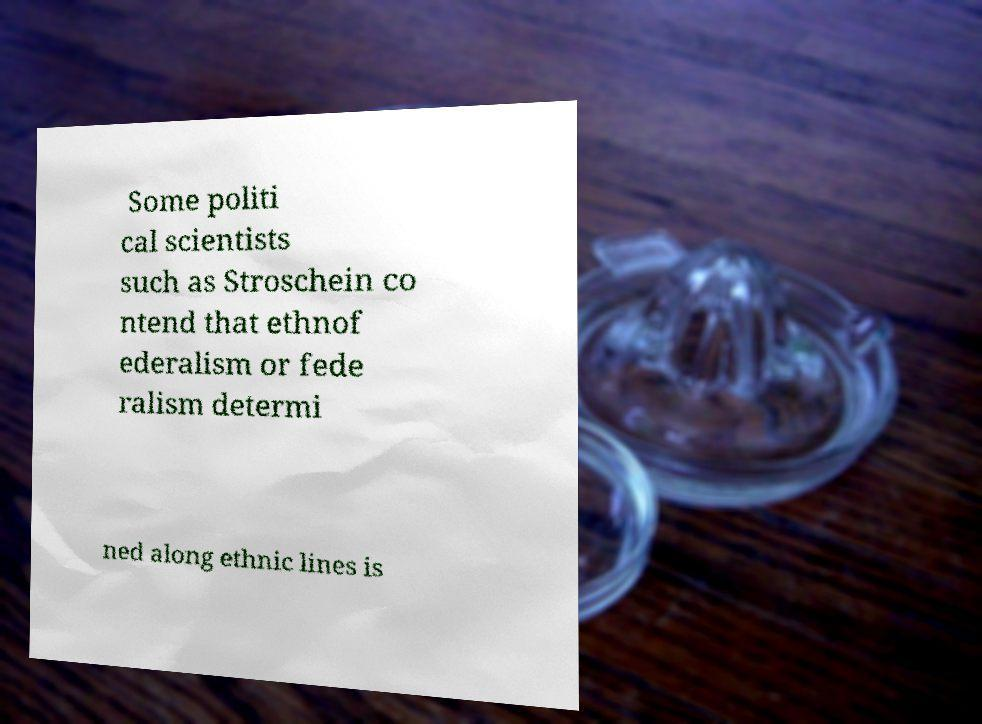There's text embedded in this image that I need extracted. Can you transcribe it verbatim? Some politi cal scientists such as Stroschein co ntend that ethnof ederalism or fede ralism determi ned along ethnic lines is 